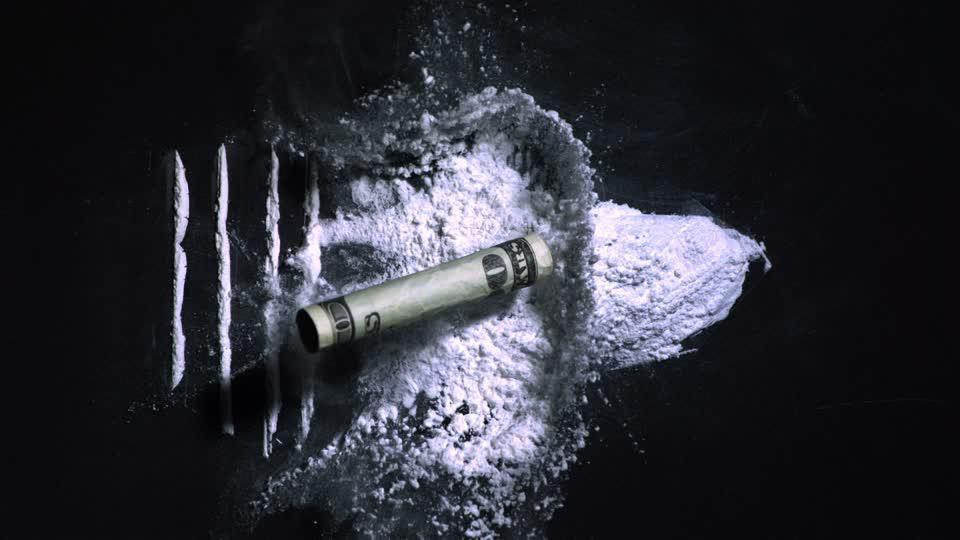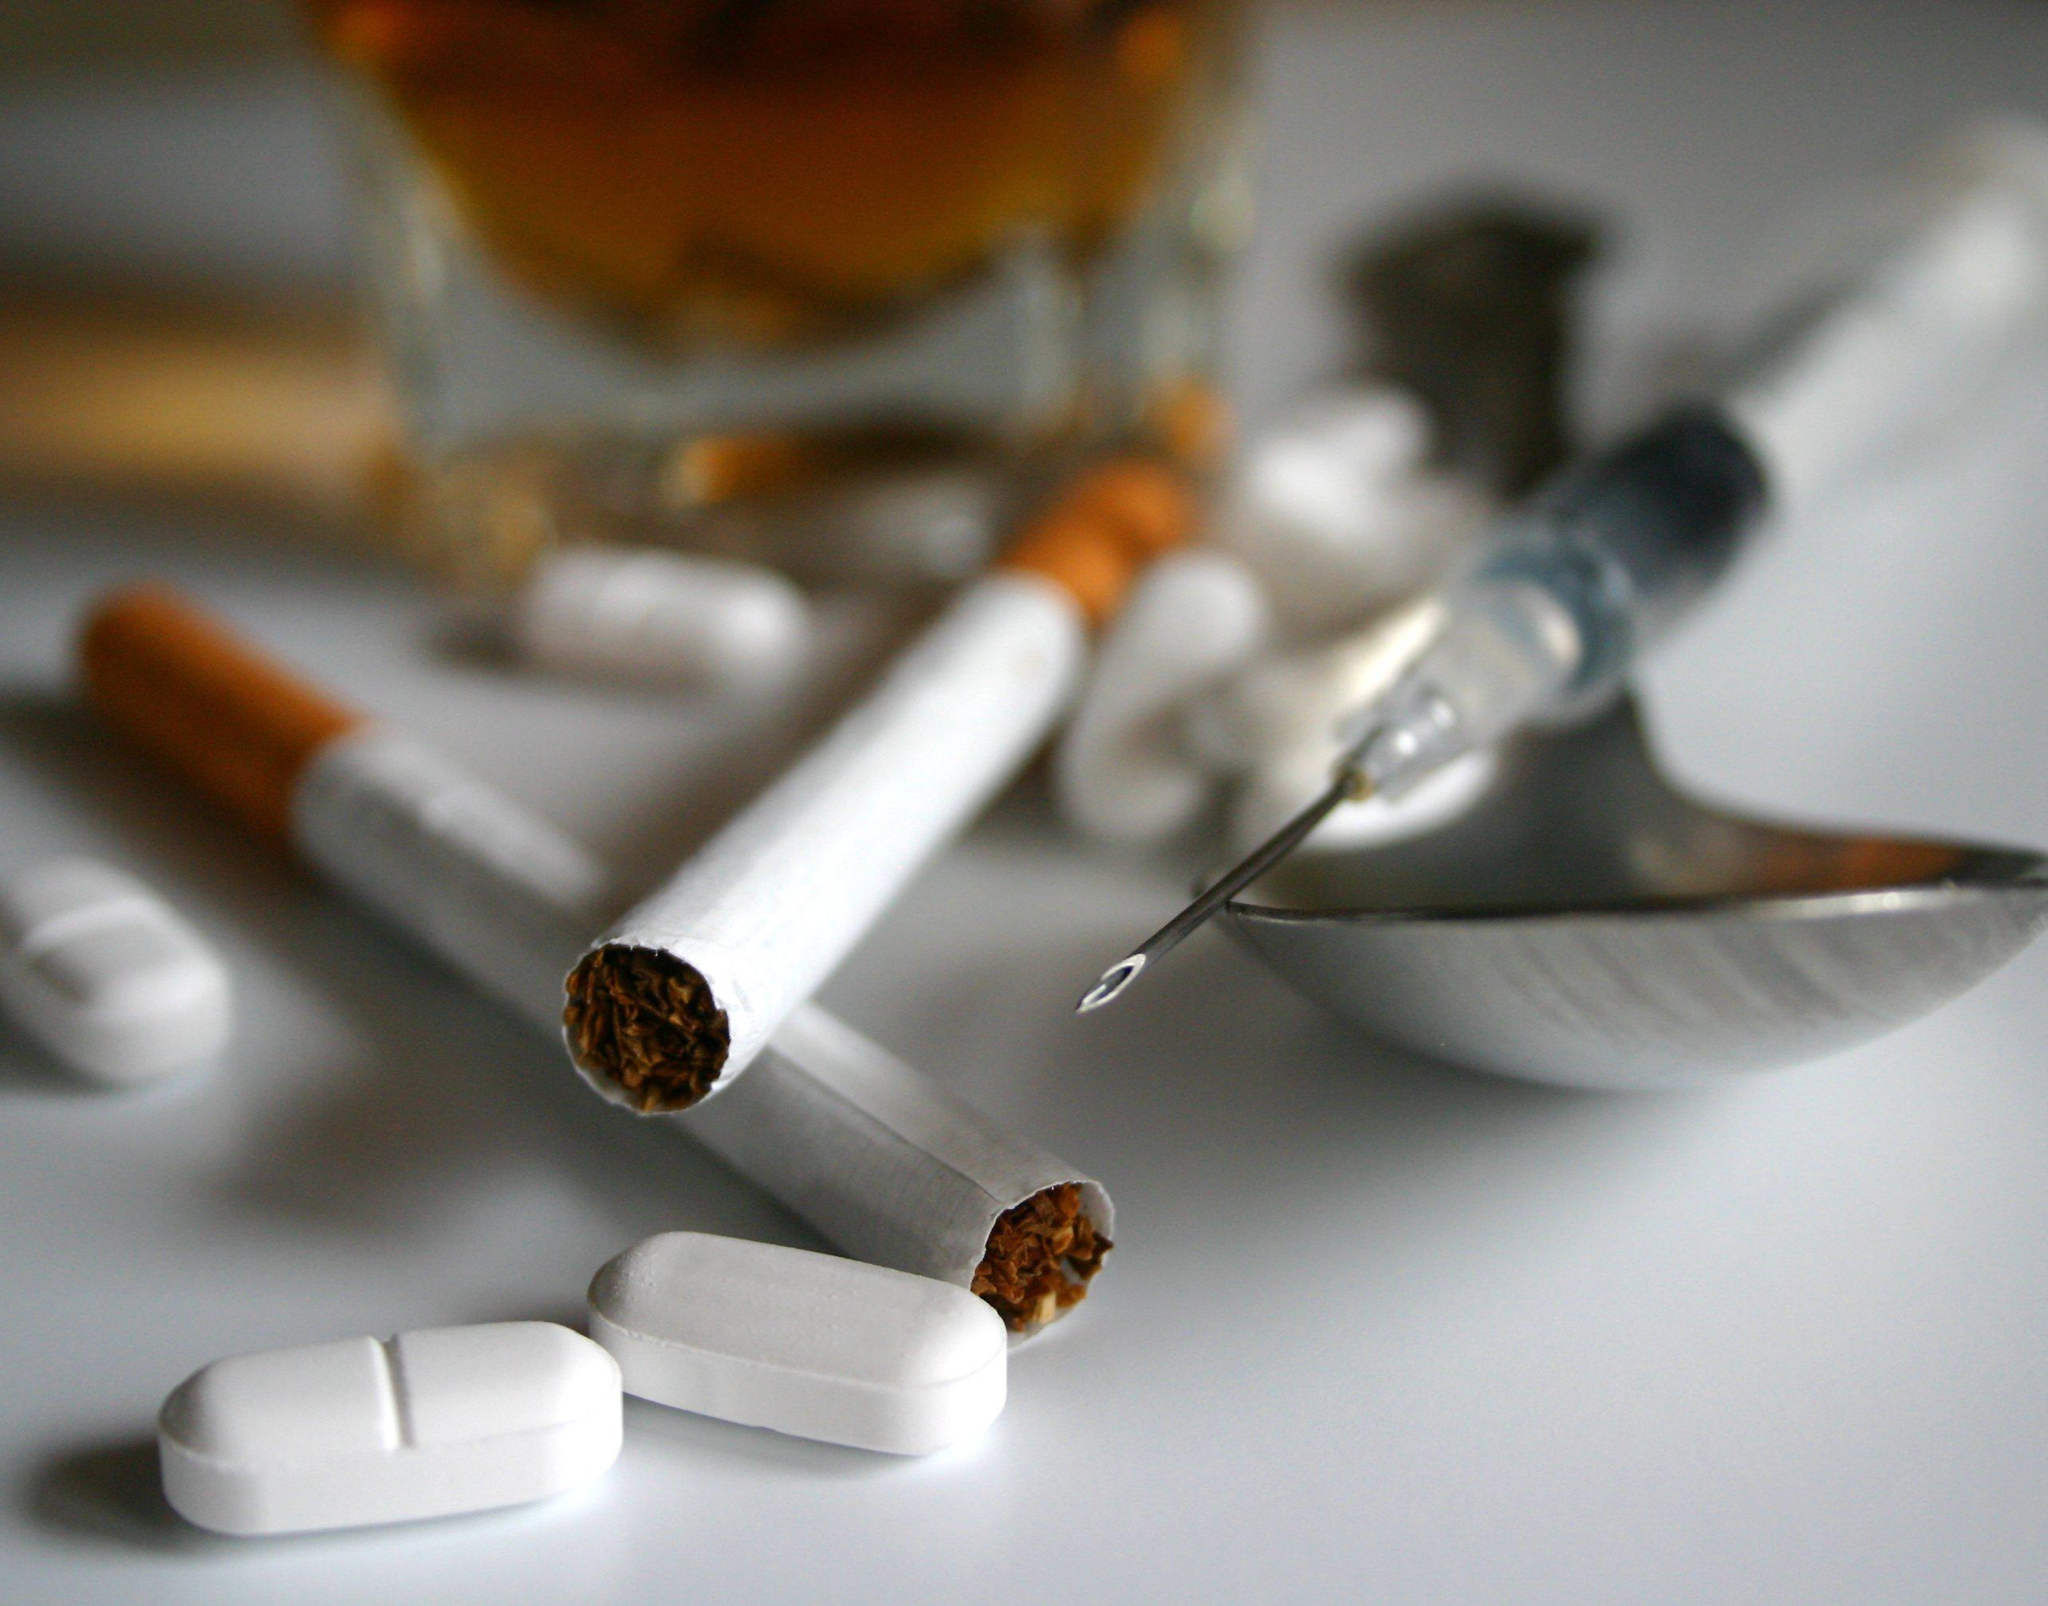The first image is the image on the left, the second image is the image on the right. Considering the images on both sides, is "There are two syringes and one spoon." valid? Answer yes or no. No. The first image is the image on the left, the second image is the image on the right. Evaluate the accuracy of this statement regarding the images: "There are two needles and one spoon.". Is it true? Answer yes or no. No. 